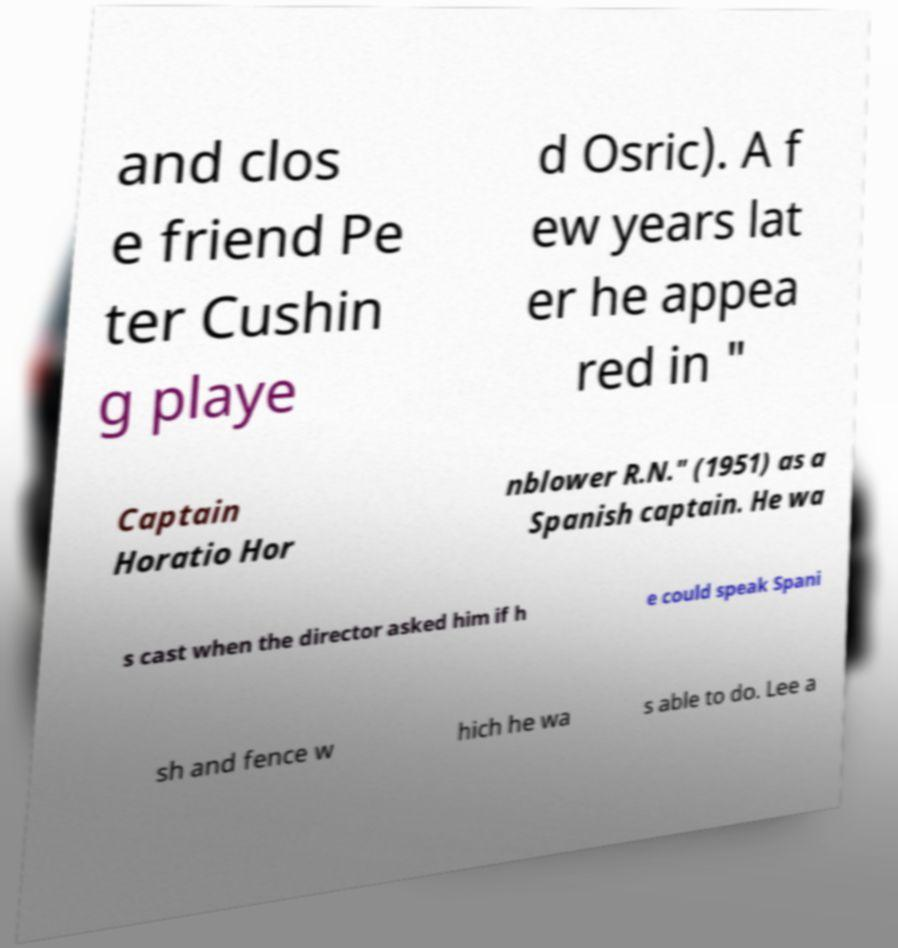There's text embedded in this image that I need extracted. Can you transcribe it verbatim? and clos e friend Pe ter Cushin g playe d Osric). A f ew years lat er he appea red in " Captain Horatio Hor nblower R.N." (1951) as a Spanish captain. He wa s cast when the director asked him if h e could speak Spani sh and fence w hich he wa s able to do. Lee a 